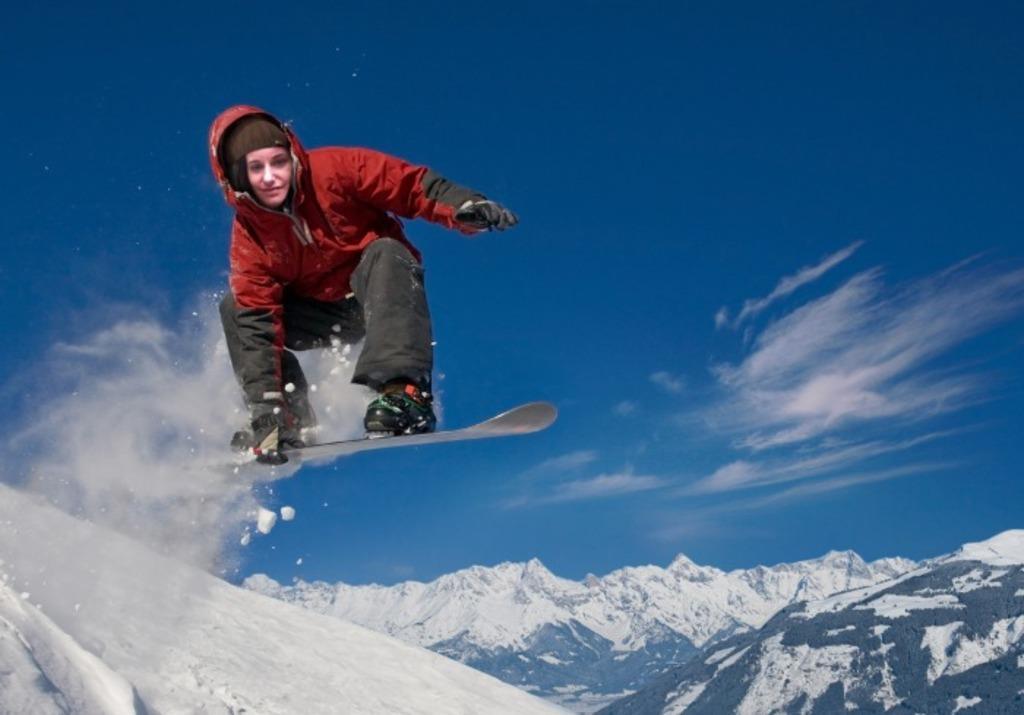How would you summarize this image in a sentence or two? In the image there is a person with ski board in the air. At the bottom of the image on the ground there is snow. In the background there are mountains with snow. At the top of the image there is sky. 